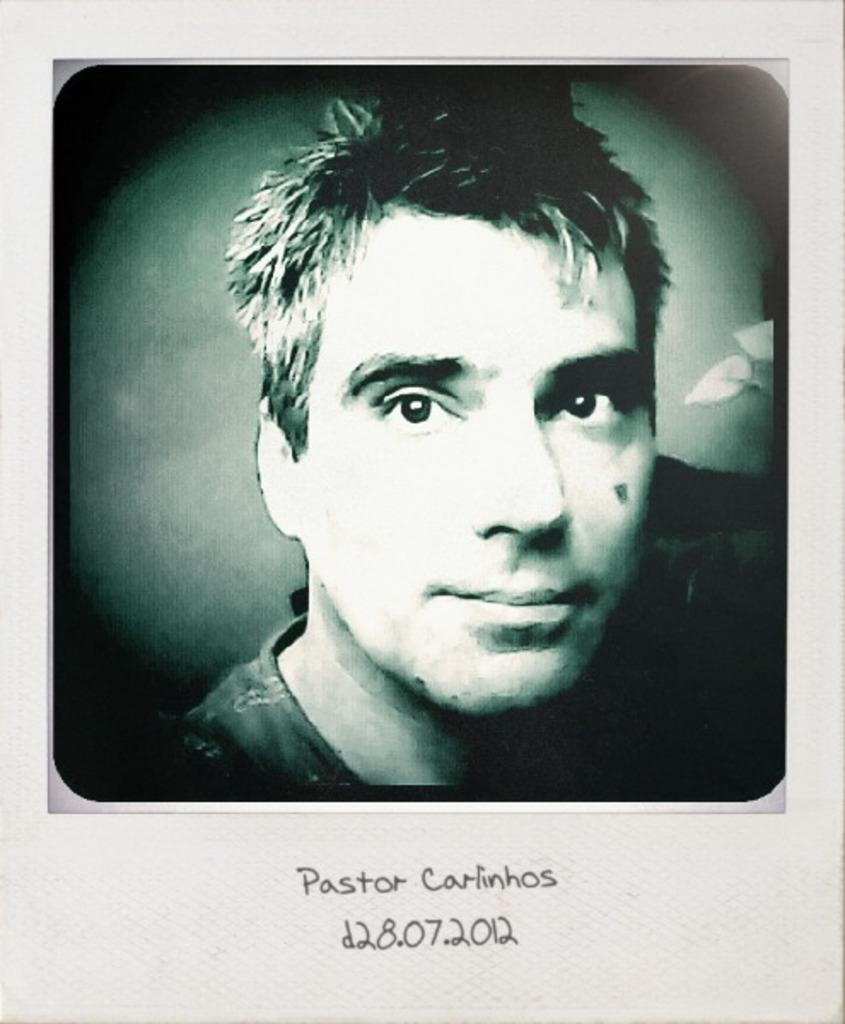What is the main subject of the image? There is a person's face in the image. What color is the background of the image? The background of the image is green. What else can be seen in the image besides the person's face? There is text or writing visible in the image. What type of insurance policy is being discussed in the image? There is no discussion of insurance policies in the image; it features a person's face and text or writing on a green background. Can you hear any sounds coming from the image? The image is visual, and there is no audio component, so no sounds can be heard. 